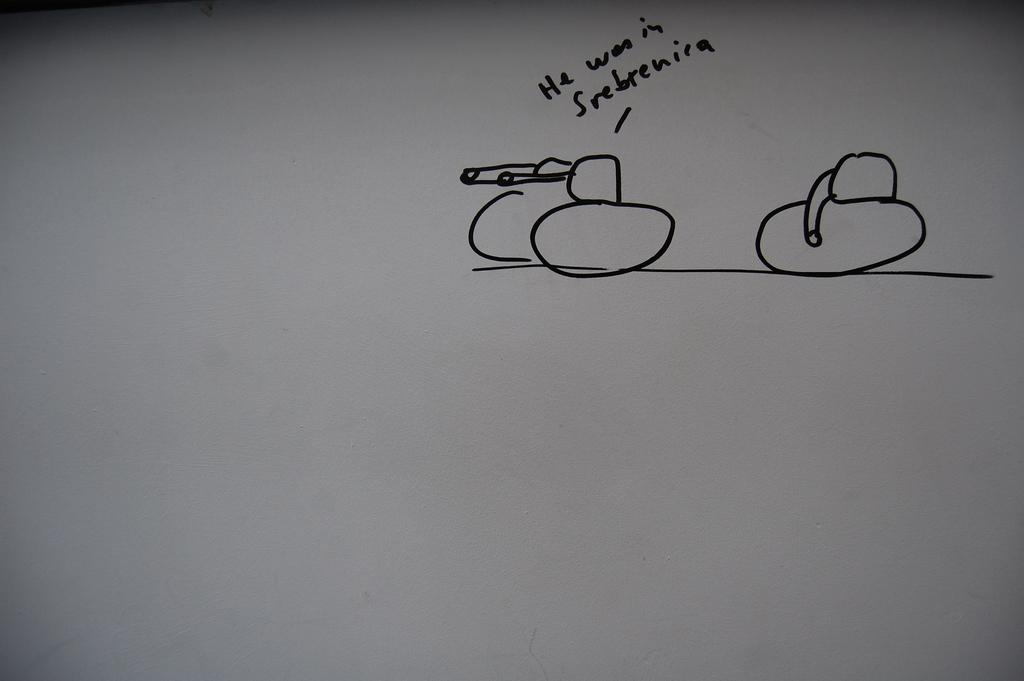<image>
Share a concise interpretation of the image provided. "He was in Srebrenira" is written on a white board. 